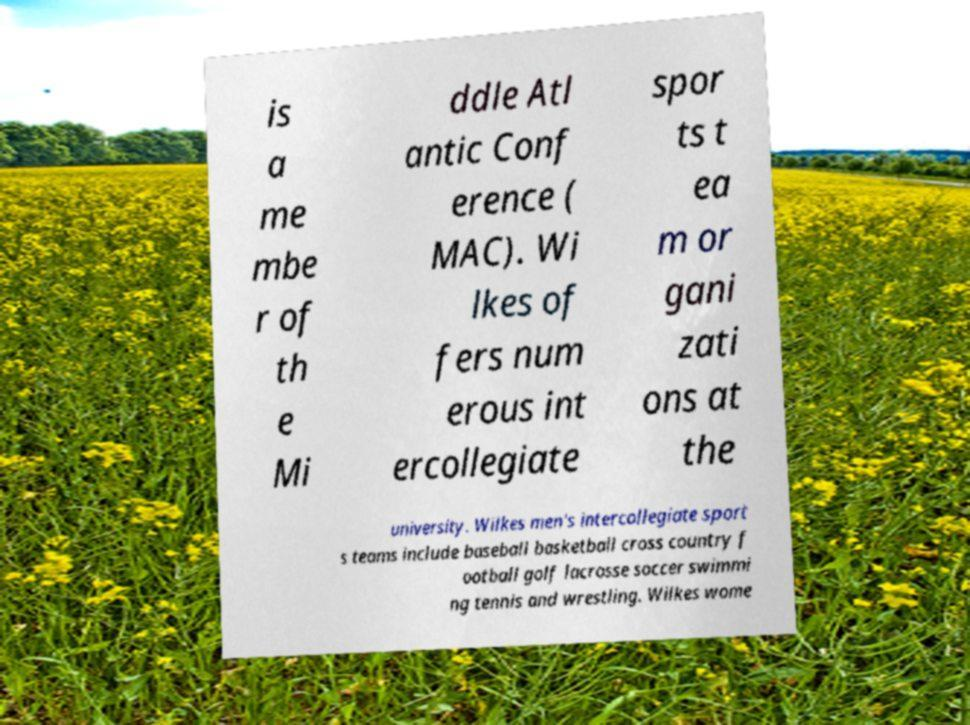For documentation purposes, I need the text within this image transcribed. Could you provide that? is a me mbe r of th e Mi ddle Atl antic Conf erence ( MAC). Wi lkes of fers num erous int ercollegiate spor ts t ea m or gani zati ons at the university. Wilkes men's intercollegiate sport s teams include baseball basketball cross country f ootball golf lacrosse soccer swimmi ng tennis and wrestling. Wilkes wome 